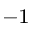<formula> <loc_0><loc_0><loc_500><loc_500>^ { - 1 }</formula> 